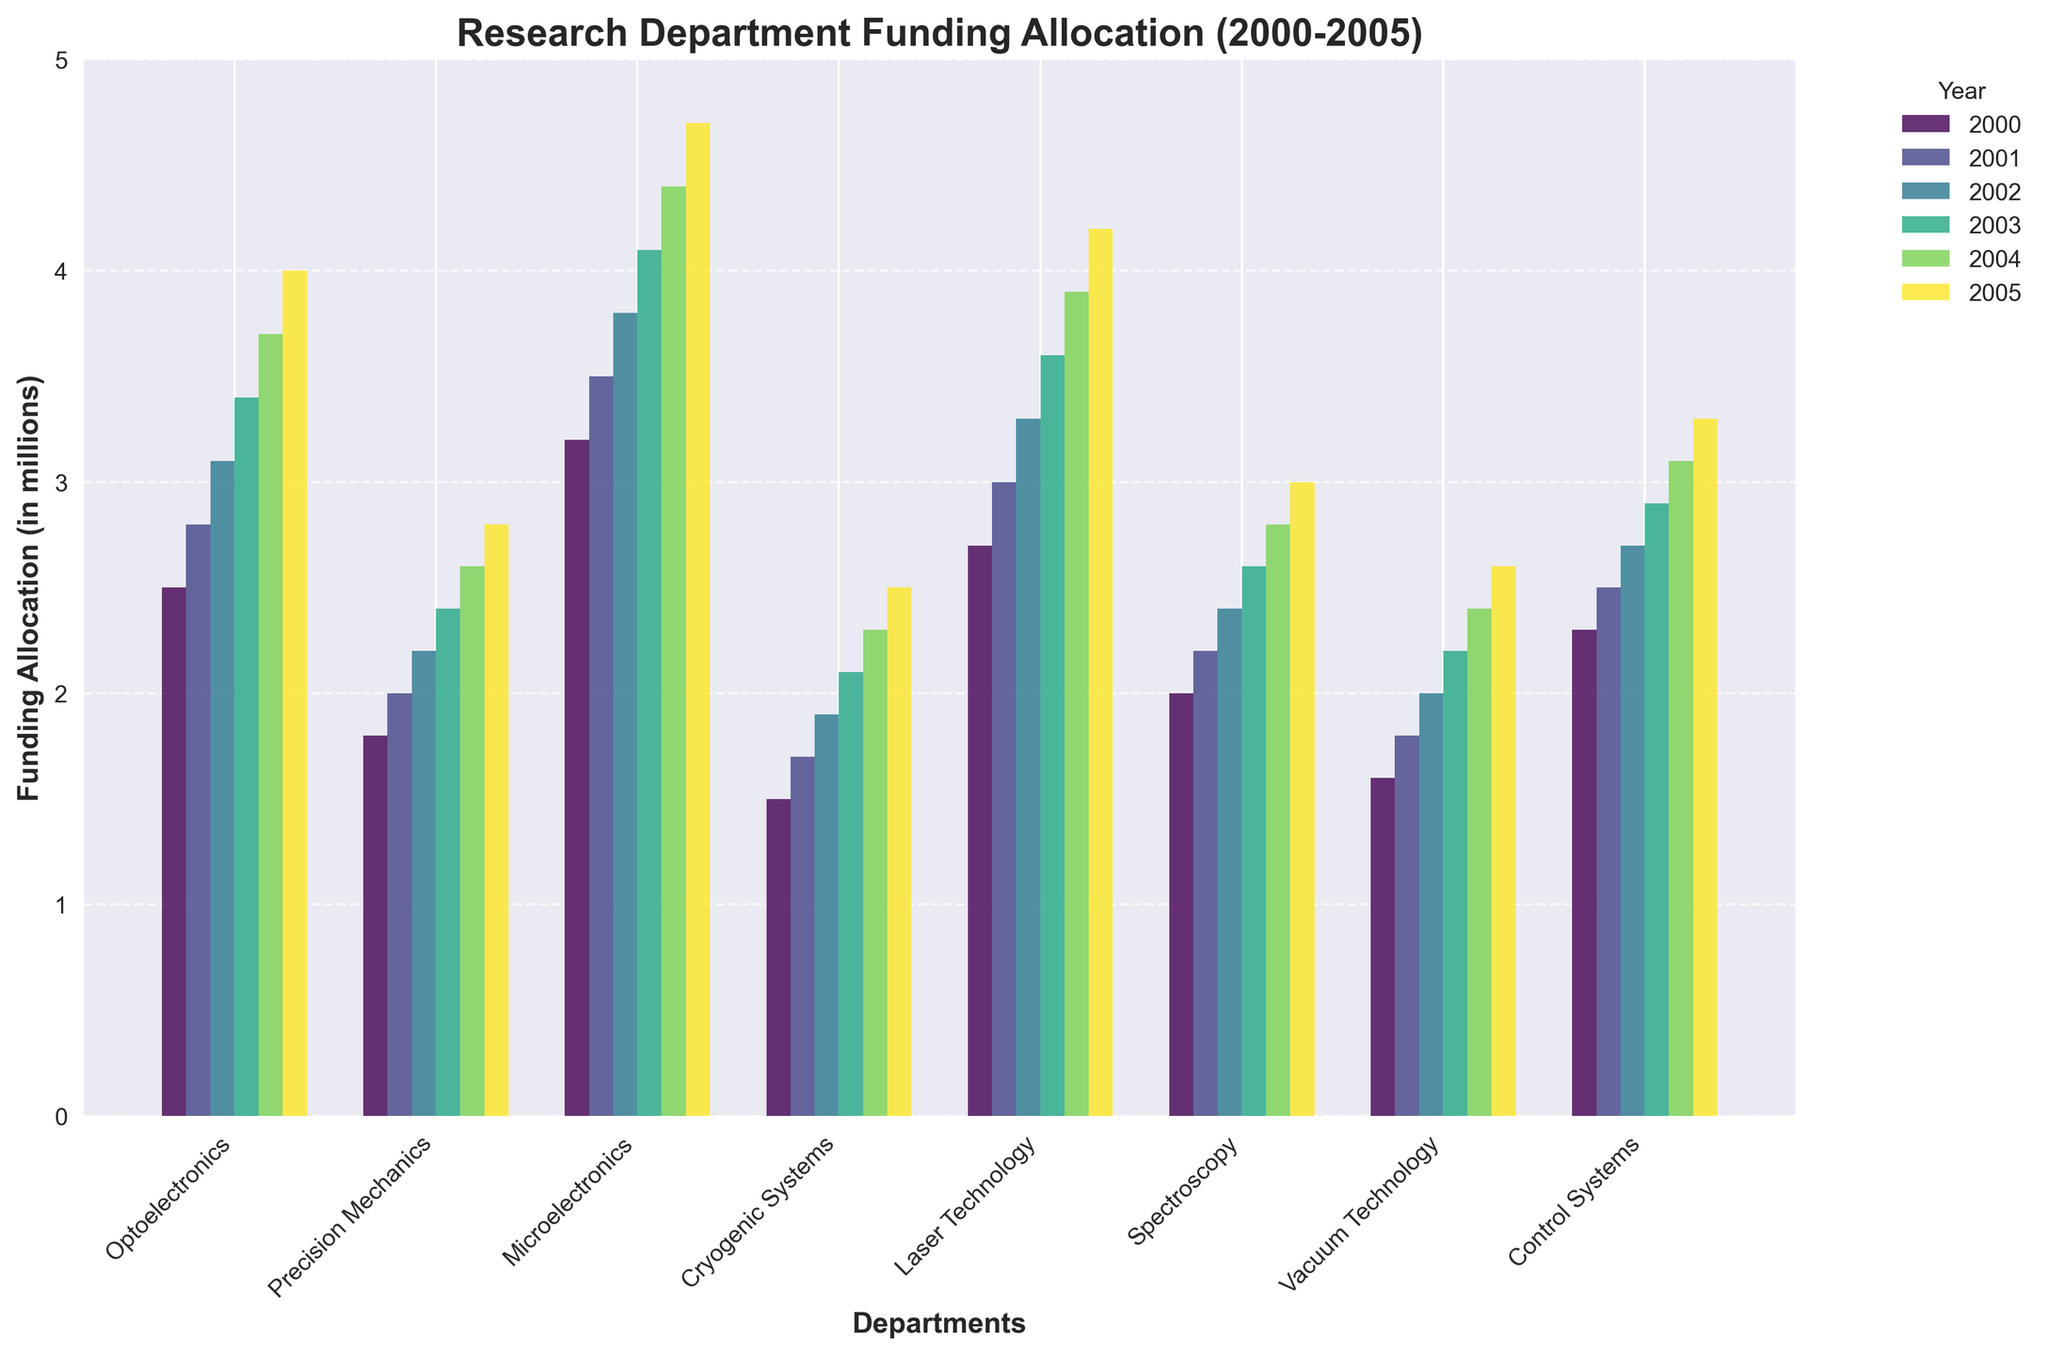Which department had the highest funding allocation in 2005? Look for the tallest bar in the 2005 section. The tallest bar corresponds to the Microelectronics department.
Answer: Microelectronics How much did Cryogenic Systems' funding increase from 2000 to 2005? Subtract the funding amount in 2000 from the funding amount in 2005 for Cryogenic Systems: 2.5 - 1.5 = 1.0
Answer: 1.0 million Which department showed the least increase in funding from 2000 to 2005? Calculate the increase for each department from 2000 to 2005 and find the smallest difference. Vacuum Technology increased from 1.6 to 2.6, which is an increase of 1.0, the least among all departments.
Answer: Vacuum Technology Among Optoelectronics, Precision Mechanics, and Laser Technology, which had the most consistent year-over-year increase? Evaluate the funding changes year by year for each department. Optoelectronics increased by 0.3 every year, while Precision Mechanics increased by 0.2, and Laser Technology by 0.3. All three had consistent increases, but Optoelectronics is mentioned first.
Answer: Optoelectronics What was the total funding allocation for all departments in 2003? Sum the funding for all departments in 2003: 3.4 + 2.4 + 4.1 + 2.1 + 3.6 + 2.6 + 2.2 + 2.9 = 23.3
Answer: 23.3 million What is the average funding for Control Systems from 2000 to 2005? Sum the funding from 2000 to 2005 and divide by the number of years: (2.3 + 2.5 + 2.7 + 2.9 + 3.1 + 3.3) / 6 = 2.8
Answer: 2.8 million Which year had the smallest difference between the highest funded and lowest funded departments? Compare the difference between the highest and lowest funded departments for each year. For example, in 2000 it's 3.2 - 1.5 = 1.7; repeat for other years. Find the smallest difference.
Answer: 2000 How much more funding did Microelectronics get compared to Spectroscopy in 2005? Subtract the funding of Spectroscopy from that of Microelectronics in 2005: 4.7 - 3.0 = 1.7
Answer: 1.7 million What department had the lowest funding across all years and what was the amount in 2000? Find the department with the smallest value in 2000. The smallest amount is for Cryogenic Systems at 1.5 million.
Answer: Cryogenic Systems, 1.5 million 